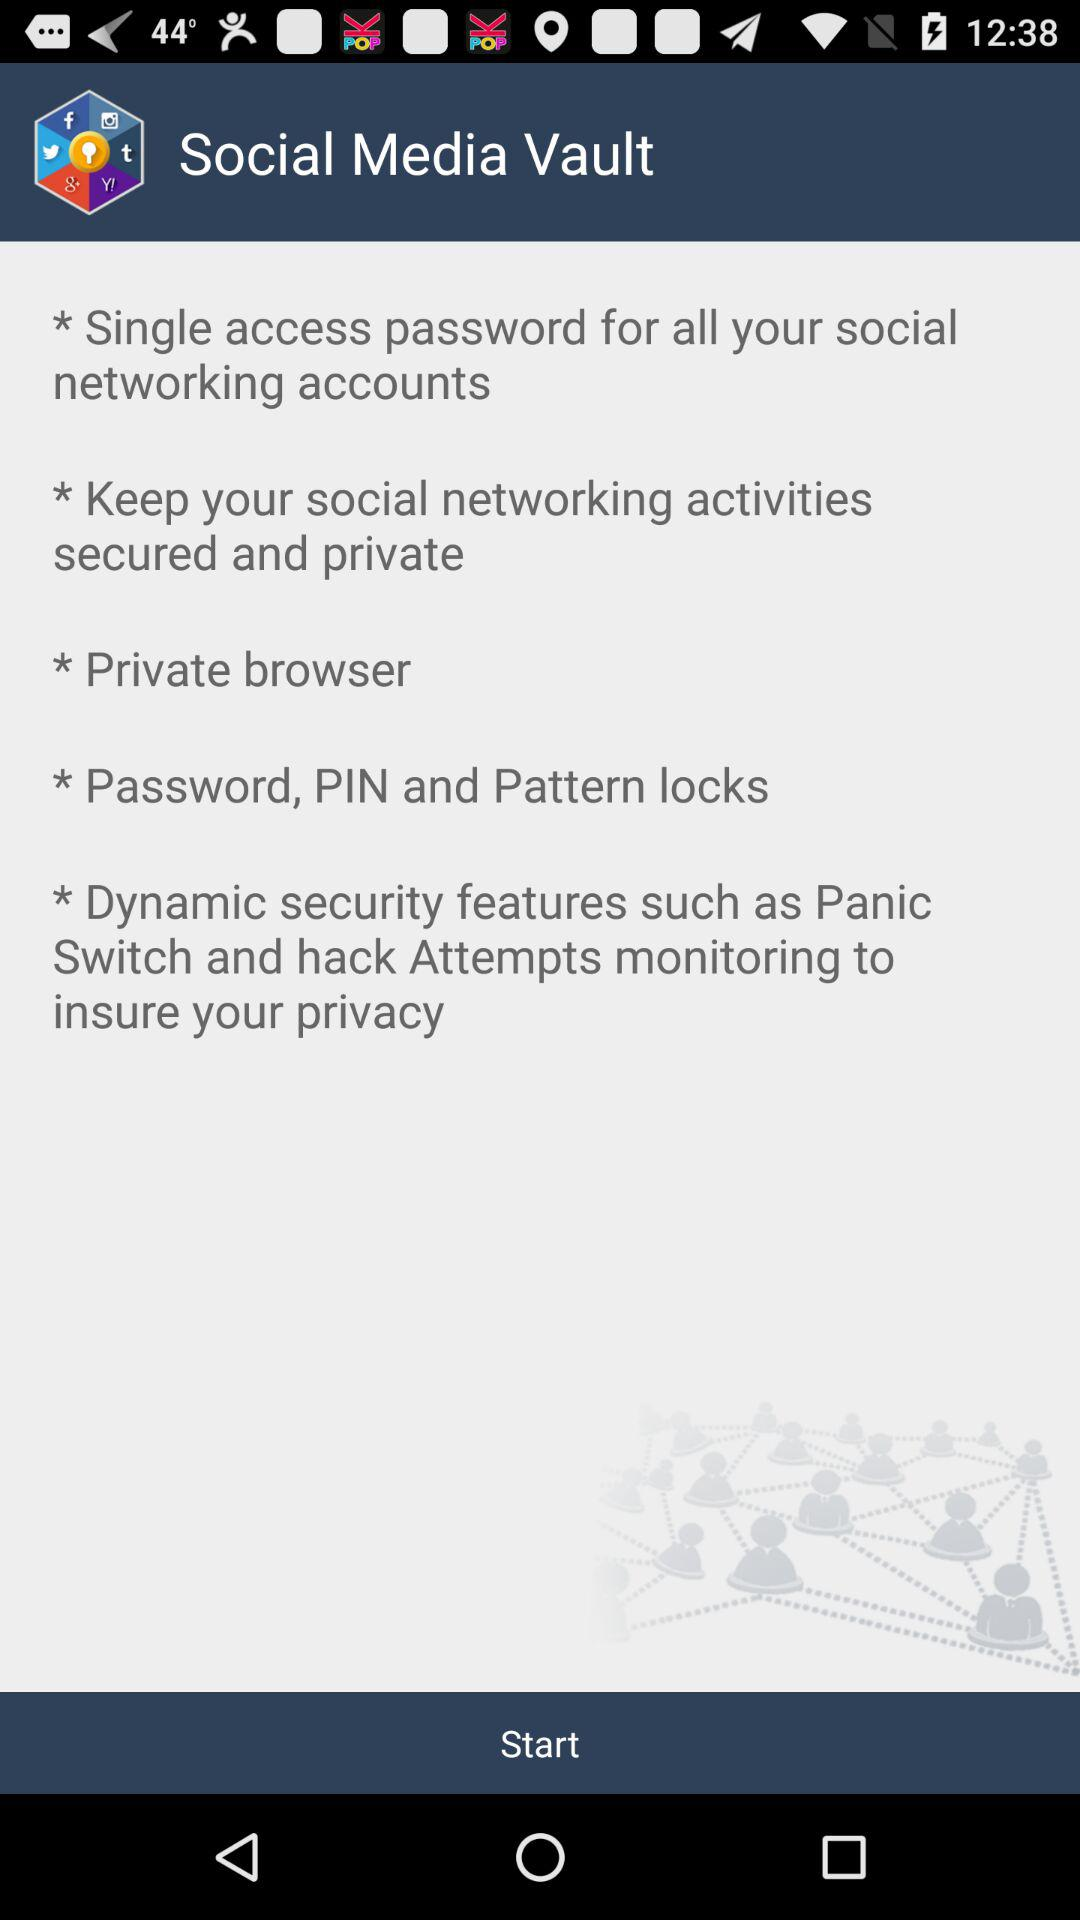What's the type of browser? The type of browser is private. 